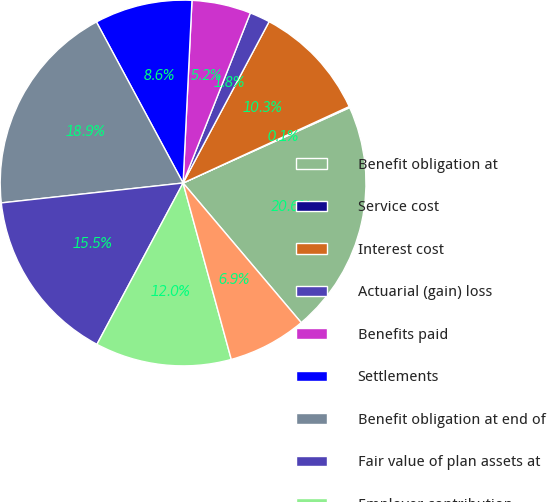<chart> <loc_0><loc_0><loc_500><loc_500><pie_chart><fcel>Benefit obligation at<fcel>Service cost<fcel>Interest cost<fcel>Actuarial (gain) loss<fcel>Benefits paid<fcel>Settlements<fcel>Benefit obligation at end of<fcel>Fair value of plan assets at<fcel>Employer contribution<fcel>Benefit payments<nl><fcel>20.59%<fcel>0.1%<fcel>10.34%<fcel>1.8%<fcel>5.22%<fcel>8.63%<fcel>18.88%<fcel>15.46%<fcel>12.05%<fcel>6.93%<nl></chart> 